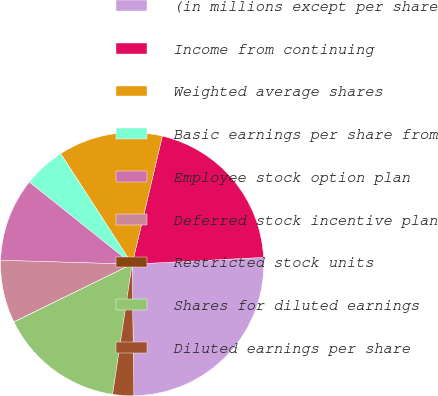Convert chart. <chart><loc_0><loc_0><loc_500><loc_500><pie_chart><fcel>(in millions except per share<fcel>Income from continuing<fcel>Weighted average shares<fcel>Basic earnings per share from<fcel>Employee stock option plan<fcel>Deferred stock incentive plan<fcel>Restricted stock units<fcel>Shares for diluted earnings<fcel>Diluted earnings per share<nl><fcel>25.61%<fcel>20.5%<fcel>12.82%<fcel>5.14%<fcel>10.26%<fcel>7.7%<fcel>0.02%<fcel>15.38%<fcel>2.58%<nl></chart> 